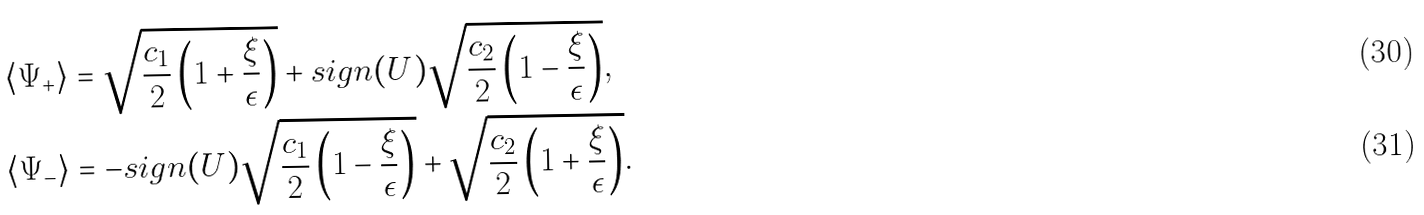Convert formula to latex. <formula><loc_0><loc_0><loc_500><loc_500>\langle \Psi _ { + } \rangle & = \sqrt { \frac { c _ { 1 } } { 2 } \left ( 1 + \frac { \xi } { \epsilon } \right ) } + s i g n ( U ) \sqrt { \frac { c _ { 2 } } { 2 } \left ( 1 - \frac { \xi } { \epsilon } \right ) } , \\ \langle \Psi _ { - } \rangle & = - s i g n ( U ) \sqrt { \frac { c _ { 1 } } { 2 } \left ( 1 - \frac { \xi } { \epsilon } \right ) } + \sqrt { \frac { c _ { 2 } } { 2 } \left ( 1 + \frac { \xi } { \epsilon } \right ) } .</formula> 